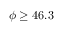<formula> <loc_0><loc_0><loc_500><loc_500>\phi \geq 4 6 . 3 \</formula> 